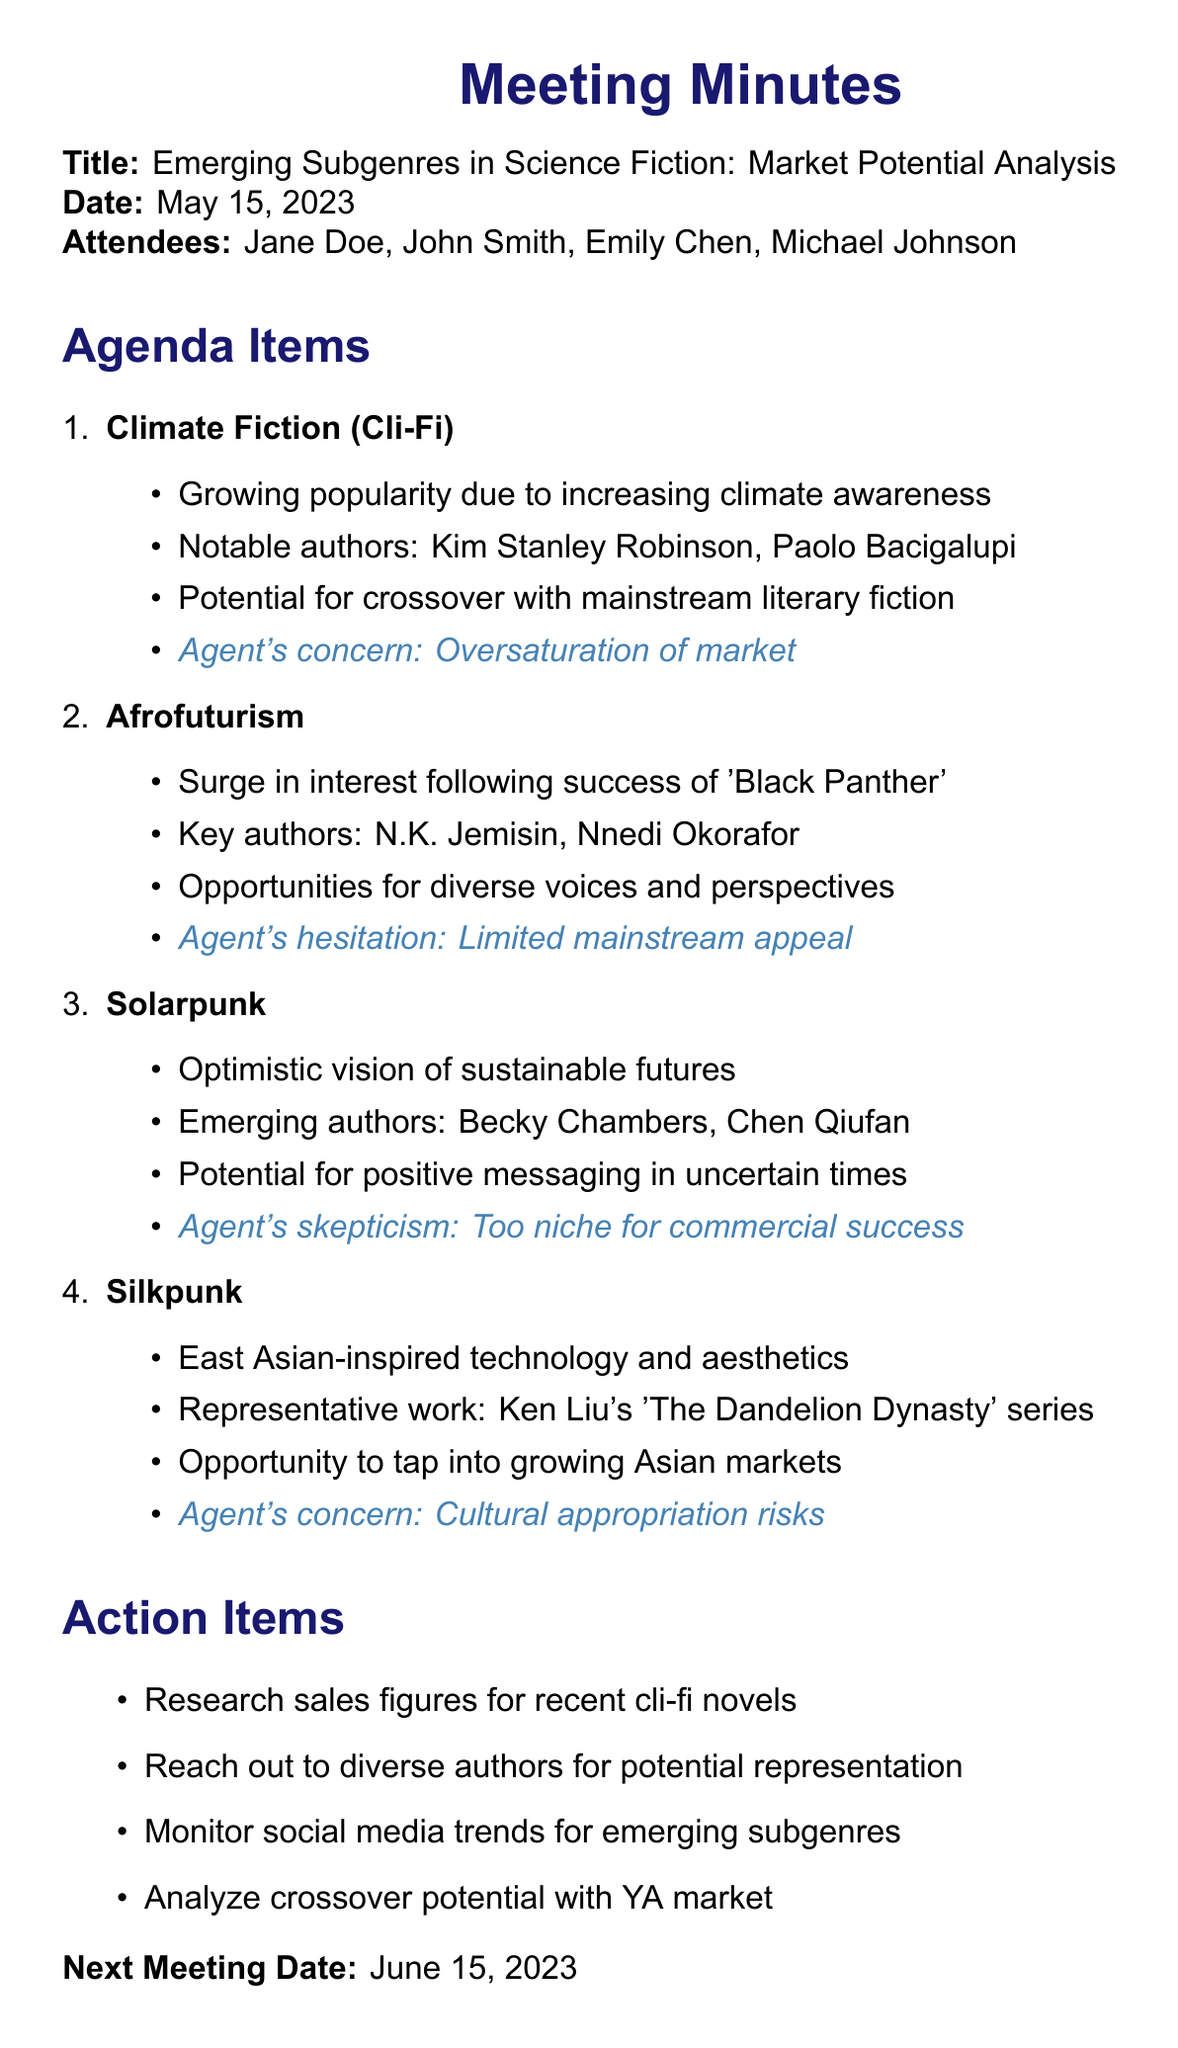What is the date of the meeting? The date of the meeting is specified in the document as "2023-05-15".
Answer: May 15, 2023 Who is the literary agent present at the meeting? The document lists attendees and identifies one of them as "Jane Doe (Literary Agent)".
Answer: Jane Doe What is one notable author mentioned in the Climate Fiction discussion? The discussion points for Climate Fiction include notable authors; one cited is "Kim Stanley Robinson".
Answer: Kim Stanley Robinson What subgenre saw a surge in interest after 'Black Panther'? The document indicates that interest increased in "Afrofuturism" following the success of 'Black Panther'.
Answer: Afrofuturism What is the agent's concern regarding Silkpunk? The document states the agent has concerns about "Cultural appropriation risks" related to Silkpunk.
Answer: Cultural appropriation risks What action item involves monitoring trends? The document includes an action item to "Monitor social media trends for emerging subgenres".
Answer: Monitor social media trends How many agenda items were discussed in the meeting? The document lists four distinct subgenre discussions under the agenda items section, indicating the number discussed.
Answer: Four What is the date of the next meeting? The document specifies the next meeting date as "2023-06-15".
Answer: June 15, 2023 